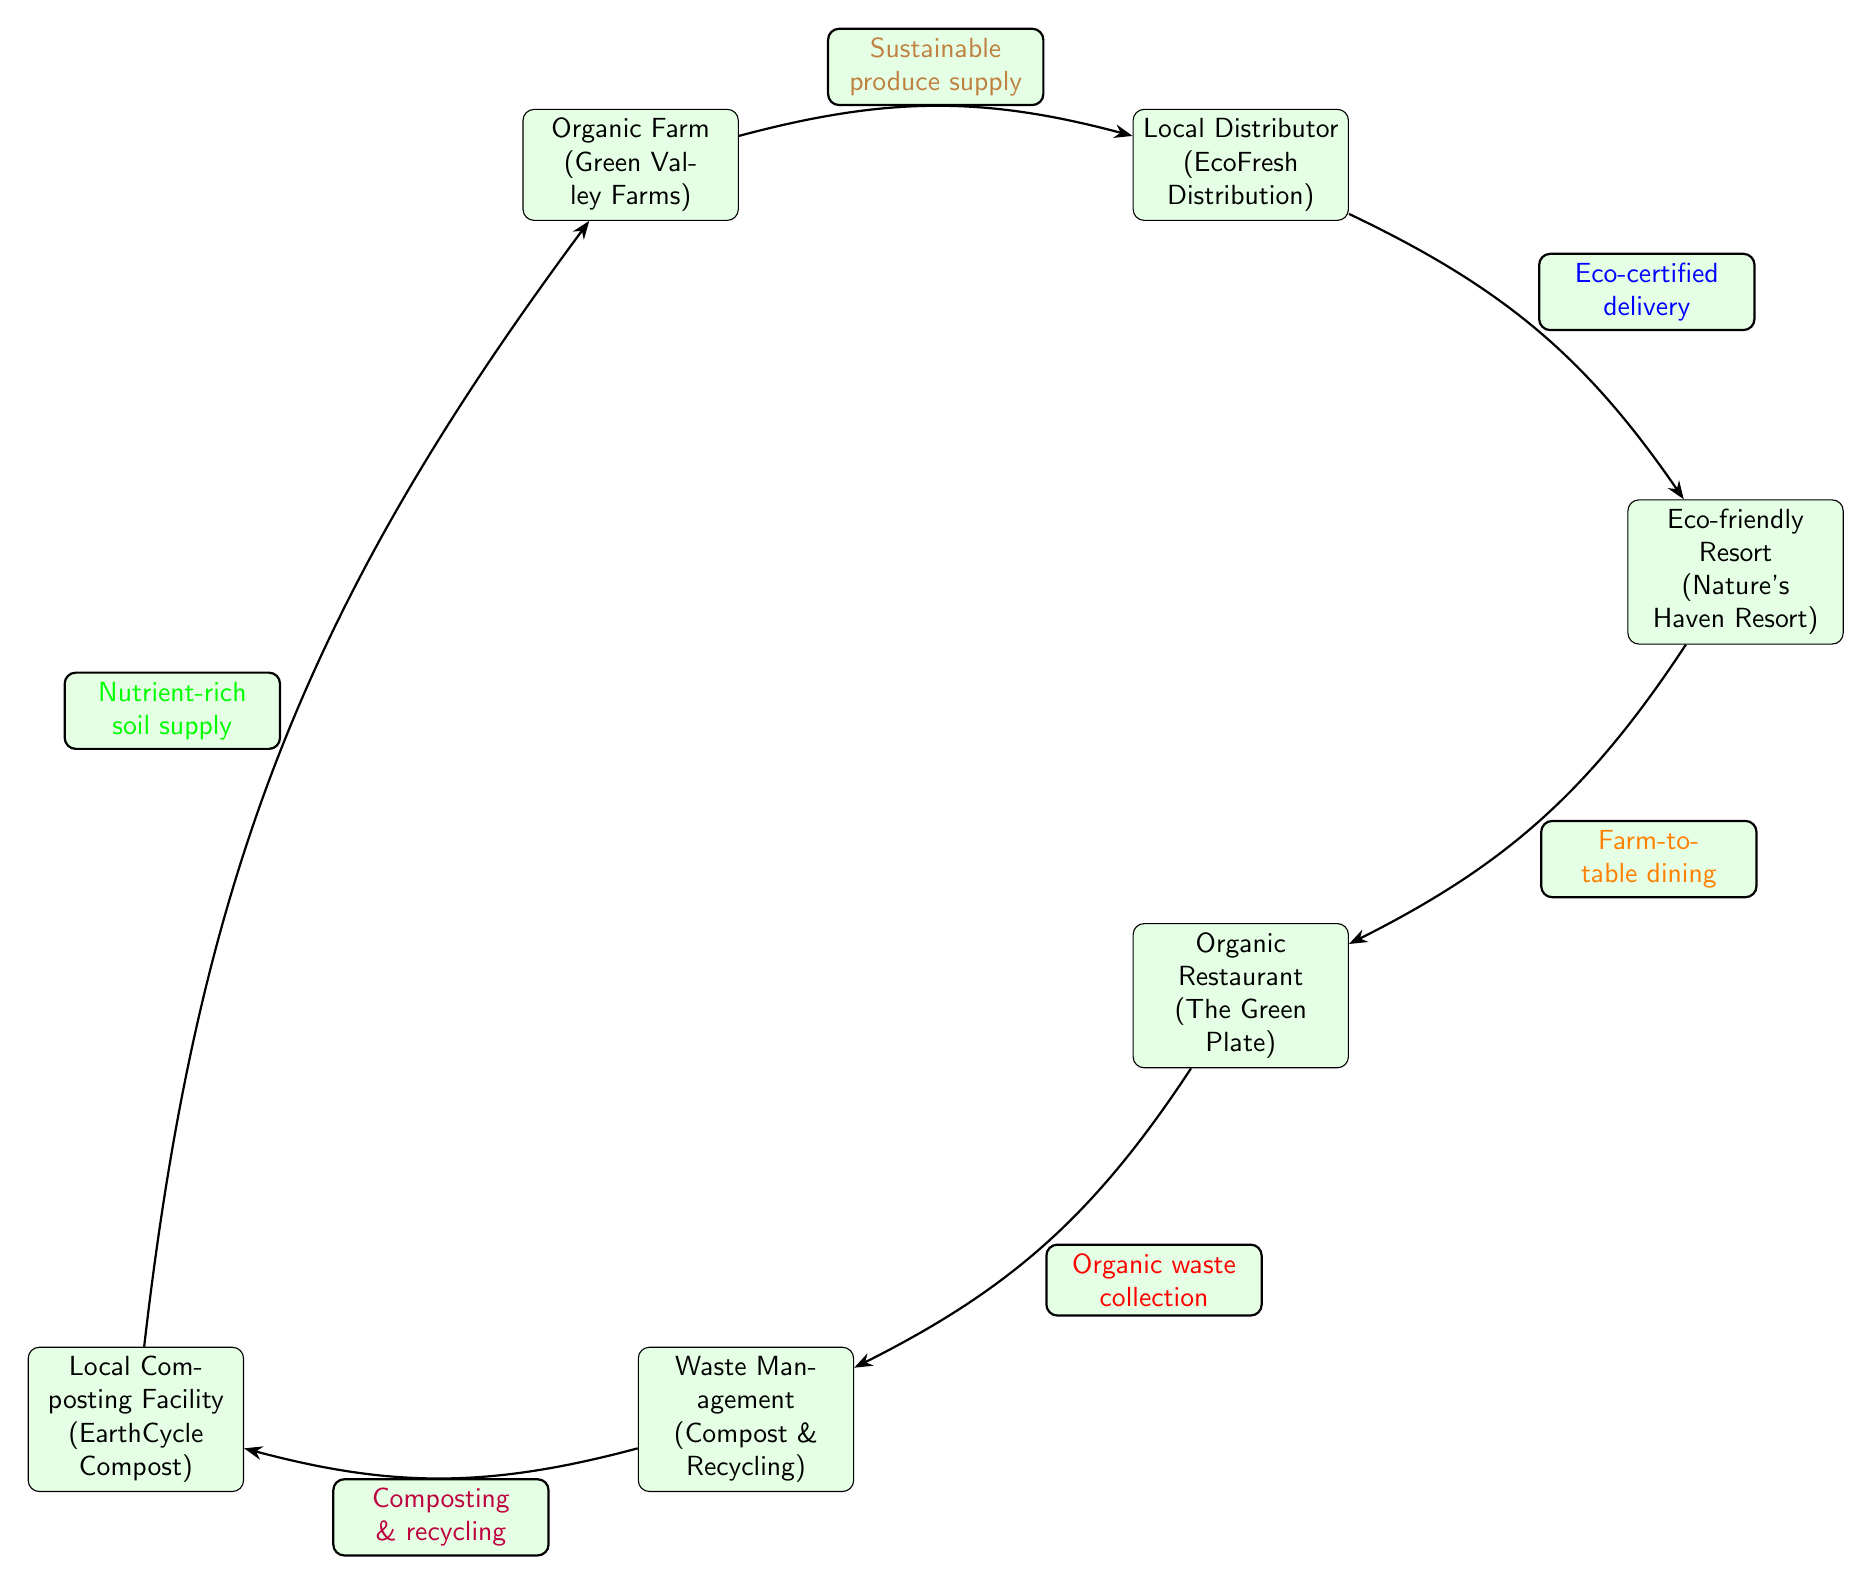What is the first node in the chain? The first node labeled in the diagram is "Organic Farm (Green Valley Farms)", which is positioned at the top left of the diagram.
Answer: Organic Farm (Green Valley Farms) How many nodes are in the diagram? By counting the distinct boxes in the diagram, we find there are six nodes total, which are connected in a chain.
Answer: 6 What is the relationship listed between the Organic Farm and the Local Distributor? The edge connecting the Organic Farm and the Local Distributor specifies "Sustainable produce supply", indicating the flow of organic produce from the farm to the distributor.
Answer: Sustainable produce supply What is the last node in the diagram? The last node displayed in the diagram is "Local Composting Facility (EarthCycle Compost)", located at the bottom left of the diagram.
Answer: Local Composting Facility (EarthCycle Compost) What type of delivery is outlined between the Local Distributor and the Eco-friendly Resort? The relationship is labeled as "Eco-certified delivery", which emphasizes the eco-friendly certification of the delivery method used.
Answer: Eco-certified delivery How does Organic Restaurant contribute to waste management? The Organic Restaurant connects to Waste Management through the label "Organic waste collection", which highlights its role in collecting organic waste for management.
Answer: Organic waste collection What is the source of nutrient-rich soil supply? The arrow indicates that the flow of nutrient-rich soil supply comes from the Local Composting Facility, and is directed towards the Organic Farm.
Answer: Local Composting Facility (EarthCycle Compost) Which node provides the eco-friendly products to the Eco-friendly Resort? The flow from the Local Distributor provides eco-friendly products, emphasizing its role as the supplier for the Eco-friendly Resort.
Answer: Local Distributor (EcoFresh Distribution) What is the relationship that describes dining at the Eco-friendly Resort? The connection is marked as "Farm-to-table dining", showing the direct supply of food from local farms to the dining experience at the resort.
Answer: Farm-to-table dining 